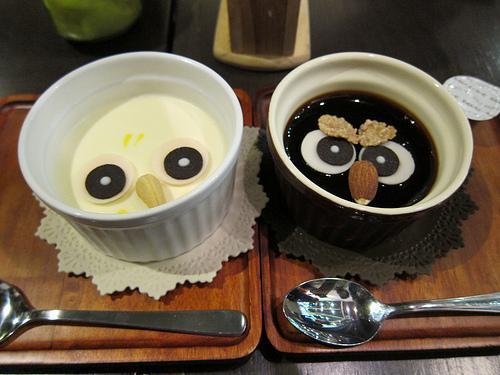How many spoons are there?
Give a very brief answer. 2. 